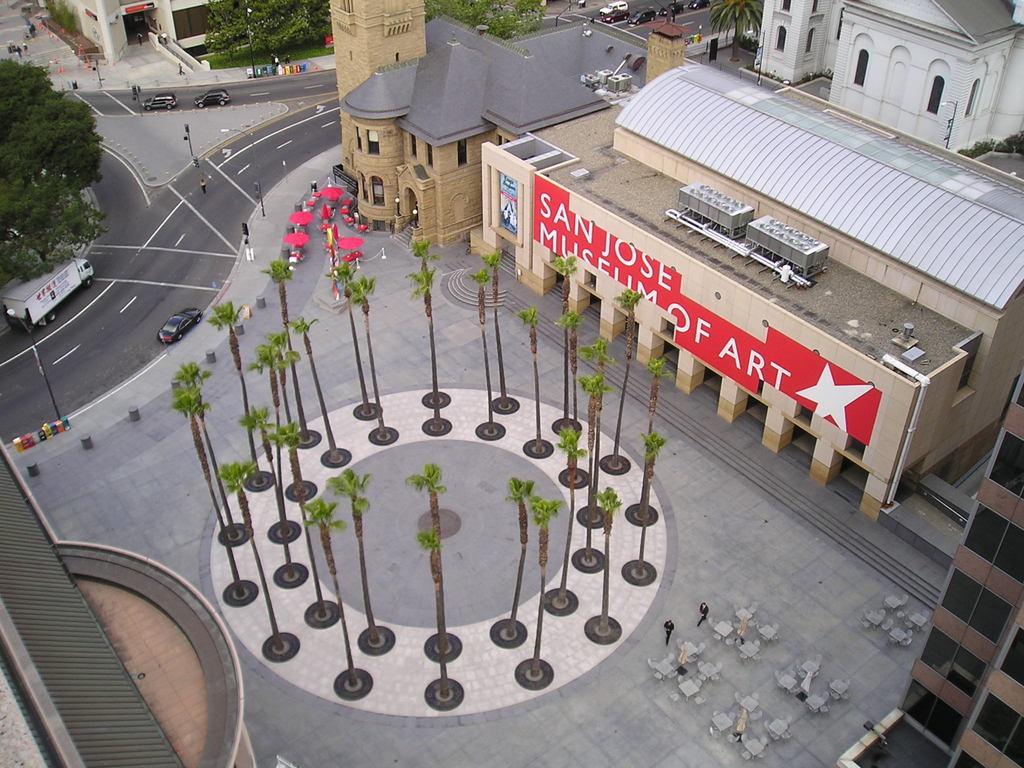In one or two sentences, can you explain what this image depicts? In this image we can see trees, buildings, persons, benches, vehicles, road, traffic signals, trees and grass. 